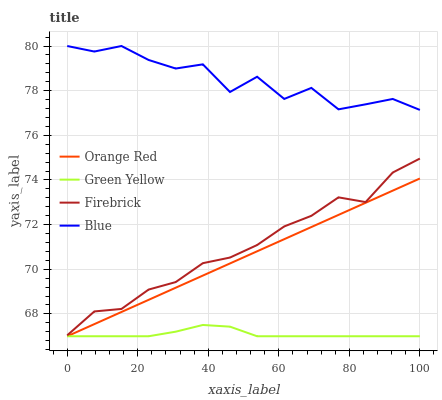Does Green Yellow have the minimum area under the curve?
Answer yes or no. Yes. Does Blue have the maximum area under the curve?
Answer yes or no. Yes. Does Firebrick have the minimum area under the curve?
Answer yes or no. No. Does Firebrick have the maximum area under the curve?
Answer yes or no. No. Is Orange Red the smoothest?
Answer yes or no. Yes. Is Blue the roughest?
Answer yes or no. Yes. Is Firebrick the smoothest?
Answer yes or no. No. Is Firebrick the roughest?
Answer yes or no. No. Does Firebrick have the lowest value?
Answer yes or no. No. Does Blue have the highest value?
Answer yes or no. Yes. Does Firebrick have the highest value?
Answer yes or no. No. Is Orange Red less than Blue?
Answer yes or no. Yes. Is Firebrick greater than Green Yellow?
Answer yes or no. Yes. Does Orange Red intersect Blue?
Answer yes or no. No. 